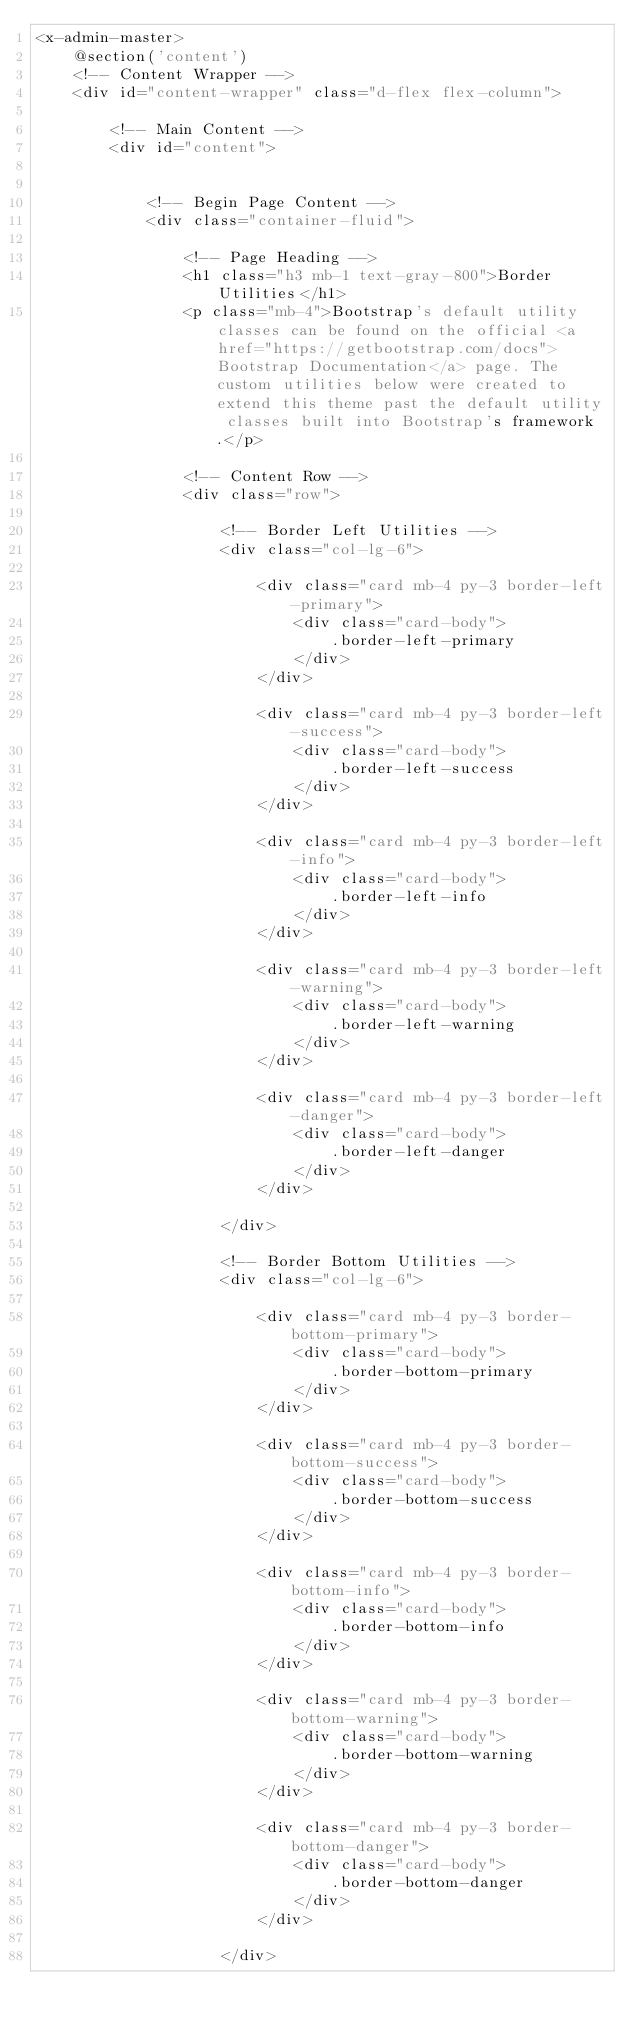<code> <loc_0><loc_0><loc_500><loc_500><_PHP_><x-admin-master>
    @section('content')
    <!-- Content Wrapper -->
    <div id="content-wrapper" class="d-flex flex-column">

        <!-- Main Content -->
        <div id="content">


            <!-- Begin Page Content -->
            <div class="container-fluid">

                <!-- Page Heading -->
                <h1 class="h3 mb-1 text-gray-800">Border Utilities</h1>
                <p class="mb-4">Bootstrap's default utility classes can be found on the official <a href="https://getbootstrap.com/docs">Bootstrap Documentation</a> page. The custom utilities below were created to extend this theme past the default utility classes built into Bootstrap's framework.</p>

                <!-- Content Row -->
                <div class="row">

                    <!-- Border Left Utilities -->
                    <div class="col-lg-6">

                        <div class="card mb-4 py-3 border-left-primary">
                            <div class="card-body">
                                .border-left-primary
                            </div>
                        </div>

                        <div class="card mb-4 py-3 border-left-success">
                            <div class="card-body">
                                .border-left-success
                            </div>
                        </div>

                        <div class="card mb-4 py-3 border-left-info">
                            <div class="card-body">
                                .border-left-info
                            </div>
                        </div>

                        <div class="card mb-4 py-3 border-left-warning">
                            <div class="card-body">
                                .border-left-warning
                            </div>
                        </div>

                        <div class="card mb-4 py-3 border-left-danger">
                            <div class="card-body">
                                .border-left-danger
                            </div>
                        </div>

                    </div>

                    <!-- Border Bottom Utilities -->
                    <div class="col-lg-6">

                        <div class="card mb-4 py-3 border-bottom-primary">
                            <div class="card-body">
                                .border-bottom-primary
                            </div>
                        </div>

                        <div class="card mb-4 py-3 border-bottom-success">
                            <div class="card-body">
                                .border-bottom-success
                            </div>
                        </div>

                        <div class="card mb-4 py-3 border-bottom-info">
                            <div class="card-body">
                                .border-bottom-info
                            </div>
                        </div>

                        <div class="card mb-4 py-3 border-bottom-warning">
                            <div class="card-body">
                                .border-bottom-warning
                            </div>
                        </div>

                        <div class="card mb-4 py-3 border-bottom-danger">
                            <div class="card-body">
                                .border-bottom-danger
                            </div>
                        </div>

                    </div>
</code> 